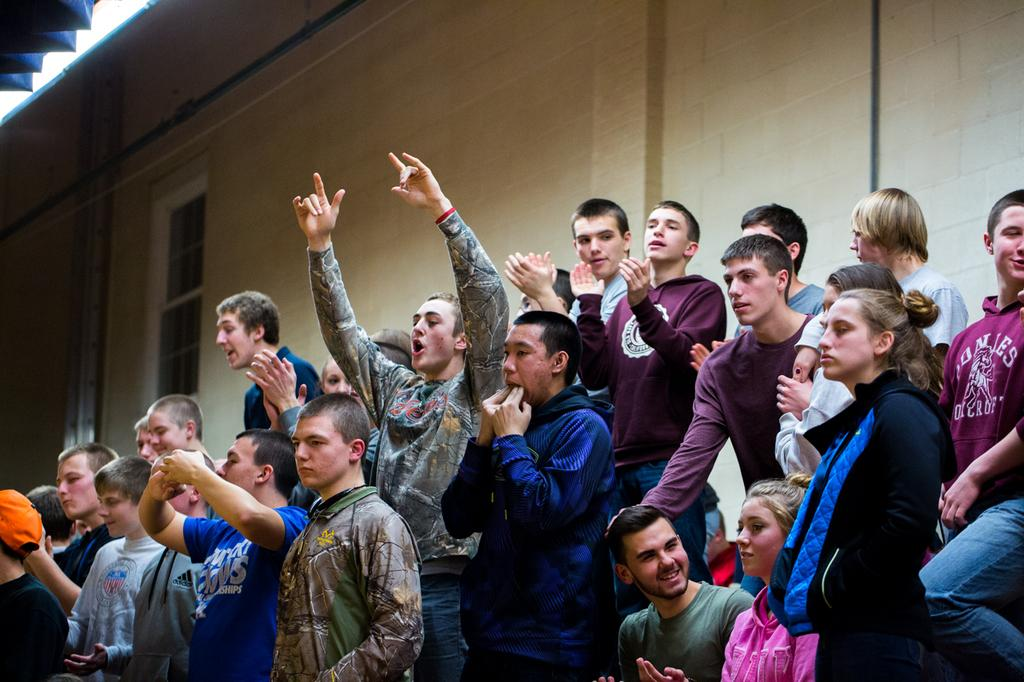How many people are in the image? There is a group of people in the image. What are some of the people doing in the image? Some people are smiling, and some are clapping their hands. Can you describe the actions of the person raising his hands? There is a person raising his hands in the image. What can be seen in the background of the image? There is a wall and a window in the background of the image. What type of cable is being used by the person in the image? There is no cable visible in the image. How many quarters can be seen in the hands of the person raising his hands? There are no quarters present in the image. 